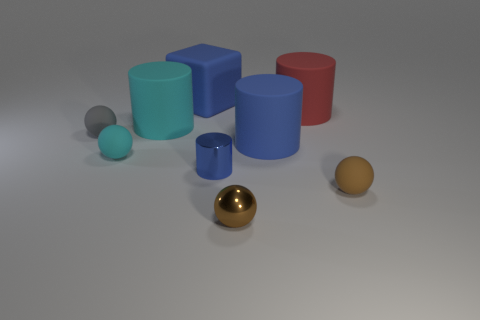The other ball that is the same color as the small metallic ball is what size?
Offer a very short reply. Small. The rubber thing that is the same color as the small metal ball is what shape?
Provide a succinct answer. Sphere. Are there fewer tiny cyan matte balls in front of the small blue cylinder than big matte spheres?
Keep it short and to the point. No. What material is the large blue thing left of the tiny blue cylinder?
Your answer should be compact. Rubber. How many other things are the same size as the blue block?
Offer a terse response. 3. Is the size of the red matte cylinder the same as the matte sphere that is right of the small metallic cylinder?
Make the answer very short. No. What shape is the gray object on the left side of the small brown ball that is in front of the tiny matte sphere that is on the right side of the brown shiny ball?
Offer a very short reply. Sphere. Is the number of tiny brown objects less than the number of large blue shiny spheres?
Give a very brief answer. No. There is a blue rubber cube; are there any tiny cyan balls behind it?
Offer a terse response. No. What shape is the rubber object that is right of the large blue cylinder and to the left of the small brown rubber object?
Offer a very short reply. Cylinder. 